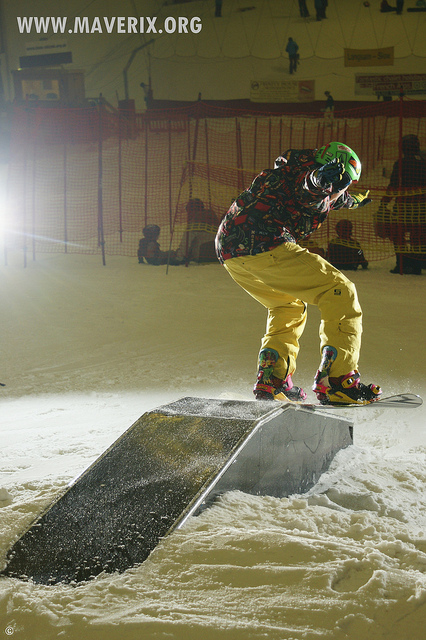Please identify all text content in this image. WWW.MAVERIX.ORG 